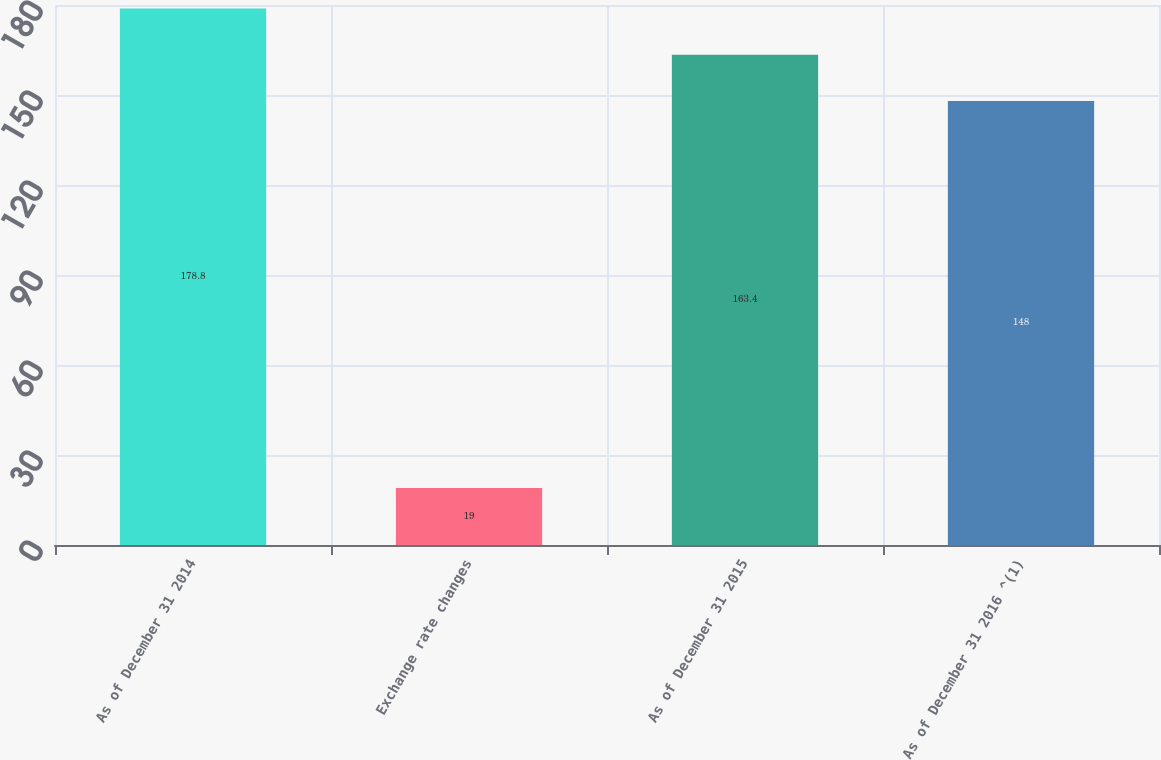Convert chart to OTSL. <chart><loc_0><loc_0><loc_500><loc_500><bar_chart><fcel>As of December 31 2014<fcel>Exchange rate changes<fcel>As of December 31 2015<fcel>As of December 31 2016 ^(1)<nl><fcel>178.8<fcel>19<fcel>163.4<fcel>148<nl></chart> 